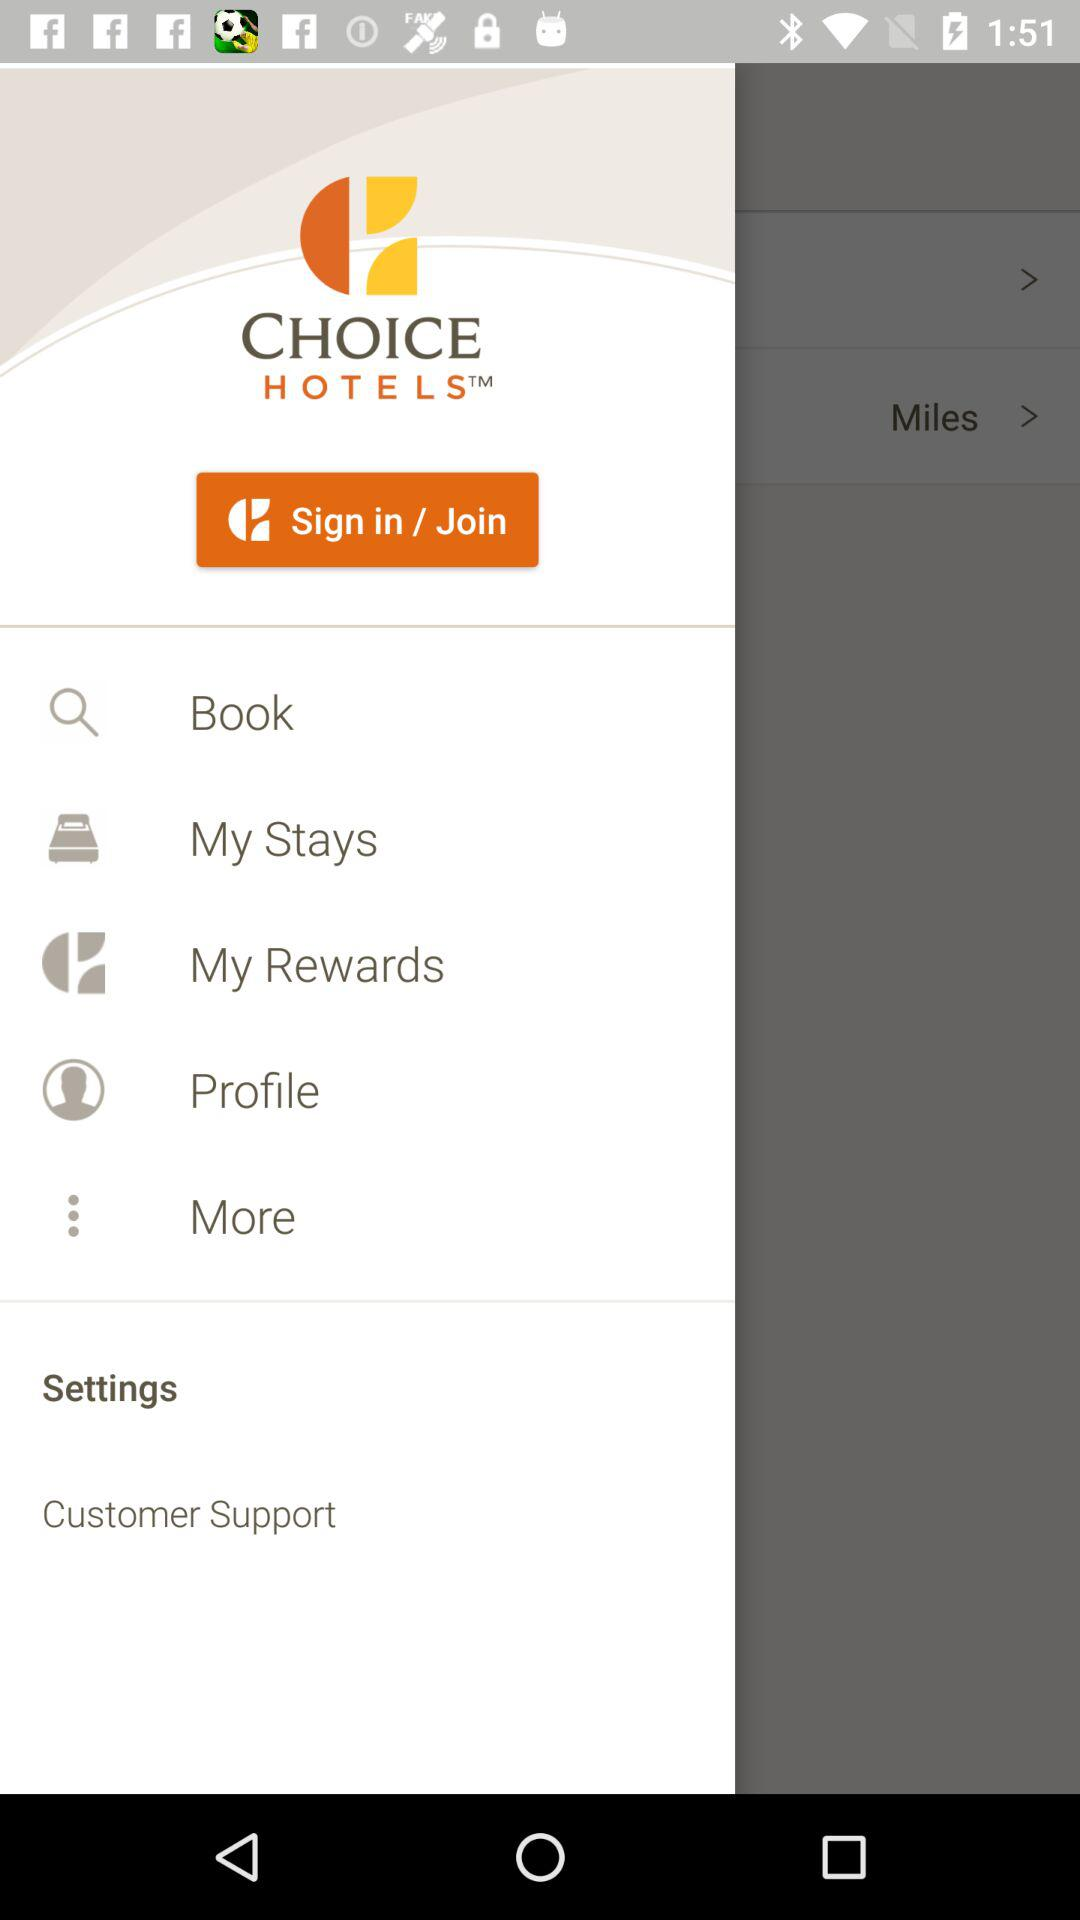What is the application name? The application name is "CHOICE HOTELS". 